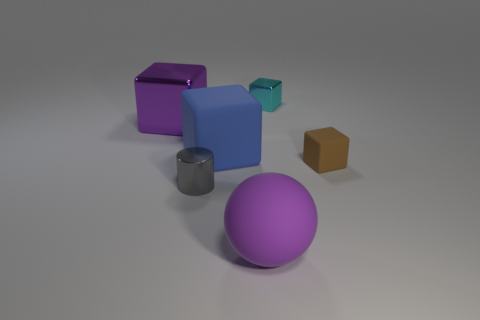Do the large shiny thing and the tiny shiny object in front of the tiny cyan shiny object have the same shape?
Keep it short and to the point. No. There is a big purple object left of the big ball; what shape is it?
Your response must be concise. Cube. Do the big purple metal object and the big blue rubber thing have the same shape?
Your answer should be very brief. Yes. There is another rubber object that is the same shape as the blue thing; what size is it?
Provide a succinct answer. Small. Does the rubber object that is right of the cyan metal block have the same size as the small cyan cube?
Provide a short and direct response. Yes. There is a thing that is both in front of the purple shiny block and on the right side of the rubber ball; what is its size?
Ensure brevity in your answer.  Small. There is a cube that is the same color as the large sphere; what is its material?
Offer a very short reply. Metal. What number of large metal blocks have the same color as the big matte sphere?
Give a very brief answer. 1. Is the number of tiny metallic cylinders on the left side of the gray cylinder the same as the number of cyan things?
Provide a short and direct response. No. What is the color of the large ball?
Make the answer very short. Purple. 